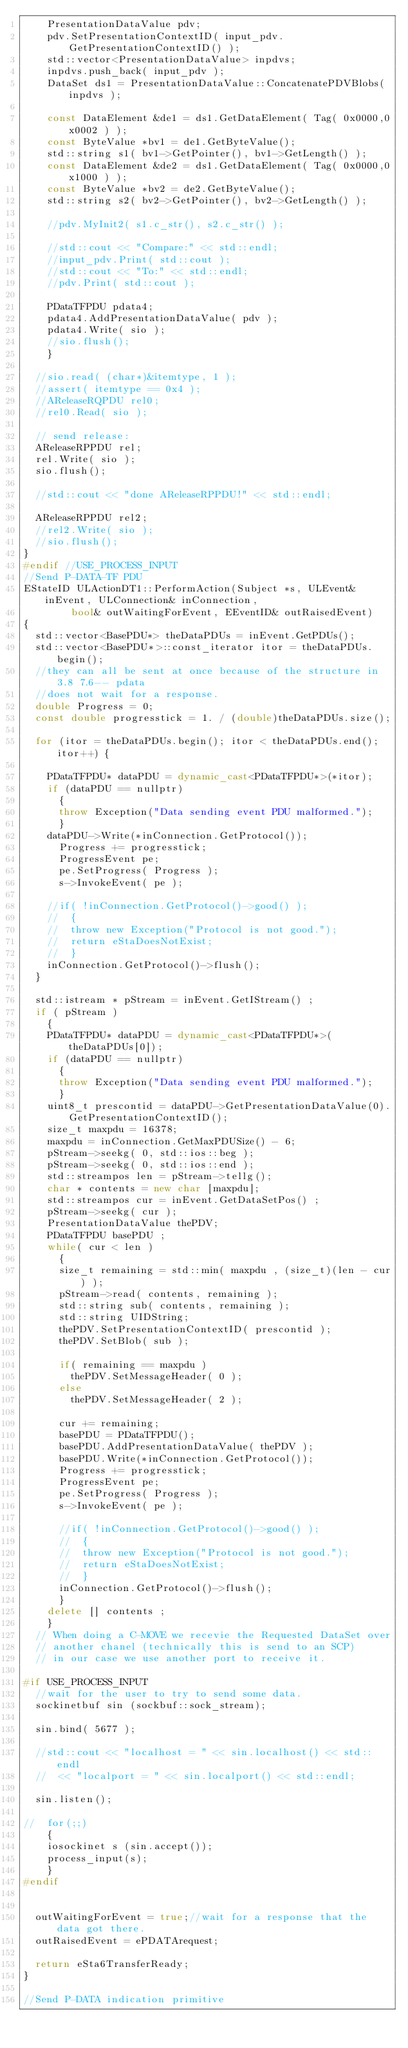<code> <loc_0><loc_0><loc_500><loc_500><_C++_>    PresentationDataValue pdv;
    pdv.SetPresentationContextID( input_pdv.GetPresentationContextID() );
    std::vector<PresentationDataValue> inpdvs;
    inpdvs.push_back( input_pdv );
    DataSet ds1 = PresentationDataValue::ConcatenatePDVBlobs( inpdvs );

    const DataElement &de1 = ds1.GetDataElement( Tag( 0x0000,0x0002 ) );
    const ByteValue *bv1 = de1.GetByteValue();
    std::string s1( bv1->GetPointer(), bv1->GetLength() );
    const DataElement &de2 = ds1.GetDataElement( Tag( 0x0000,0x1000 ) );
    const ByteValue *bv2 = de2.GetByteValue();
    std::string s2( bv2->GetPointer(), bv2->GetLength() );

    //pdv.MyInit2( s1.c_str(), s2.c_str() );

    //std::cout << "Compare:" << std::endl;
    //input_pdv.Print( std::cout );
    //std::cout << "To:" << std::endl;
    //pdv.Print( std::cout );

    PDataTFPDU pdata4;
    pdata4.AddPresentationDataValue( pdv );
    pdata4.Write( sio );
    //sio.flush();
    }

  //sio.read( (char*)&itemtype, 1 );
  //assert( itemtype == 0x4 );
  //AReleaseRQPDU rel0;
  //rel0.Read( sio );

  // send release:
  AReleaseRPPDU rel;
  rel.Write( sio );
  sio.flush();

  //std::cout << "done AReleaseRPPDU!" << std::endl;

  AReleaseRPPDU rel2;
  //rel2.Write( sio );
  //sio.flush();
}
#endif //USE_PROCESS_INPUT
//Send P-DATA-TF PDU
EStateID ULActionDT1::PerformAction(Subject *s, ULEvent& inEvent, ULConnection& inConnection,
        bool& outWaitingForEvent, EEventID& outRaisedEvent)
{
  std::vector<BasePDU*> theDataPDUs = inEvent.GetPDUs();
  std::vector<BasePDU*>::const_iterator itor = theDataPDUs.begin();
  //they can all be sent at once because of the structure in 3.8 7.6-- pdata
  //does not wait for a response.
  double Progress = 0;
  const double progresstick = 1. / (double)theDataPDUs.size();

  for (itor = theDataPDUs.begin(); itor < theDataPDUs.end(); itor++) {

    PDataTFPDU* dataPDU = dynamic_cast<PDataTFPDU*>(*itor);
    if (dataPDU == nullptr)
      {
      throw Exception("Data sending event PDU malformed.");
      }
    dataPDU->Write(*inConnection.GetProtocol());
      Progress += progresstick;
      ProgressEvent pe;
      pe.SetProgress( Progress );
      s->InvokeEvent( pe );

    //if( !inConnection.GetProtocol()->good() );
    //  {
    //  throw new Exception("Protocol is not good.");
    //  return eStaDoesNotExist;
    //  }
    inConnection.GetProtocol()->flush();
  }

  std::istream * pStream = inEvent.GetIStream() ;
  if ( pStream )
    {
    PDataTFPDU* dataPDU = dynamic_cast<PDataTFPDU*>(theDataPDUs[0]);
    if (dataPDU == nullptr)
      {
      throw Exception("Data sending event PDU malformed.");
      }
    uint8_t prescontid = dataPDU->GetPresentationDataValue(0).GetPresentationContextID();
    size_t maxpdu = 16378;
    maxpdu = inConnection.GetMaxPDUSize() - 6;
    pStream->seekg( 0, std::ios::beg );
    pStream->seekg( 0, std::ios::end );
    std::streampos len = pStream->tellg();
    char * contents = new char [maxpdu];
    std::streampos cur = inEvent.GetDataSetPos() ;
    pStream->seekg( cur );
    PresentationDataValue thePDV;
    PDataTFPDU basePDU ;
    while( cur < len )
      {
      size_t remaining = std::min( maxpdu , (size_t)(len - cur) );
      pStream->read( contents, remaining );
      std::string sub( contents, remaining );
      std::string UIDString;
      thePDV.SetPresentationContextID( prescontid );
      thePDV.SetBlob( sub );

      if( remaining == maxpdu )
        thePDV.SetMessageHeader( 0 );
      else
        thePDV.SetMessageHeader( 2 );

      cur += remaining;
      basePDU = PDataTFPDU();
      basePDU.AddPresentationDataValue( thePDV );
      basePDU.Write(*inConnection.GetProtocol());
      Progress += progresstick;
      ProgressEvent pe;
      pe.SetProgress( Progress );
      s->InvokeEvent( pe );

      //if( !inConnection.GetProtocol()->good() );
      //  {
      //  throw new Exception("Protocol is not good.");
      //  return eStaDoesNotExist;
      //  }
      inConnection.GetProtocol()->flush();
      }
    delete [] contents ;
    }
  // When doing a C-MOVE we recevie the Requested DataSet over
  // another chanel (technically this is send to an SCP)
  // in our case we use another port to receive it.

#if USE_PROCESS_INPUT
  //wait for the user to try to send some data.
  sockinetbuf sin (sockbuf::sock_stream);

  sin.bind( 5677 );

  //std::cout << "localhost = " << sin.localhost() << std::endl
  //  << "localport = " << sin.localport() << std::endl;

  sin.listen();

//  for(;;)
    {
    iosockinet s (sin.accept());
    process_input(s);
    }
#endif


  outWaitingForEvent = true;//wait for a response that the data got there.
  outRaisedEvent = ePDATArequest;

  return eSta6TransferReady;
}

//Send P-DATA indication primitive</code> 